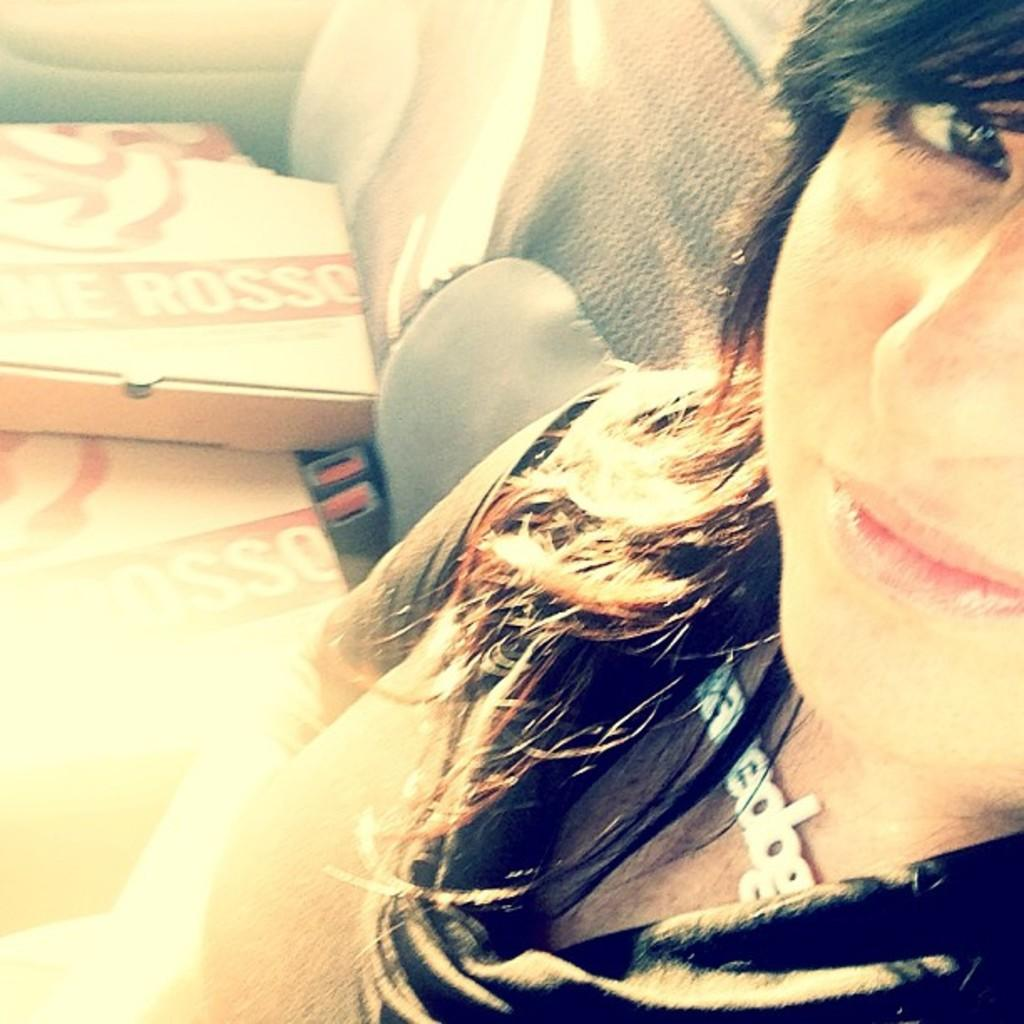What is the person in the image doing? There is a person sitting inside the vehicle. What can be seen on the seat of the vehicle? There are boxes on the seat of the vehicle. What type of mice can be seen running around in the field outside the vehicle? There are no mice or fields present in the image; it only shows a person sitting inside a vehicle with boxes on the seat. 